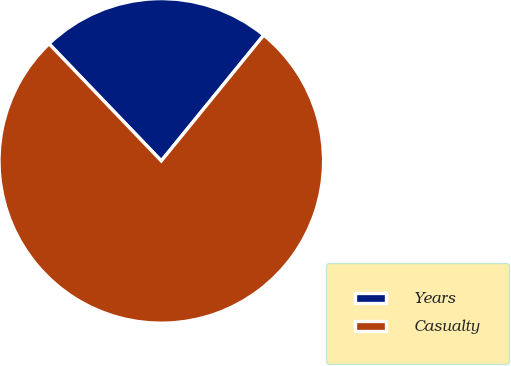Convert chart to OTSL. <chart><loc_0><loc_0><loc_500><loc_500><pie_chart><fcel>Years<fcel>Casualty<nl><fcel>23.04%<fcel>76.96%<nl></chart> 